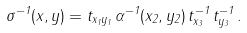<formula> <loc_0><loc_0><loc_500><loc_500>\sigma ^ { - 1 } ( x , y ) = t _ { x _ { 1 } y _ { 1 } } \, \alpha ^ { - 1 } ( x _ { 2 } , y _ { 2 } ) \, t ^ { - 1 } _ { x _ { 3 } } \, t ^ { - 1 } _ { y _ { 3 } } \, .</formula> 